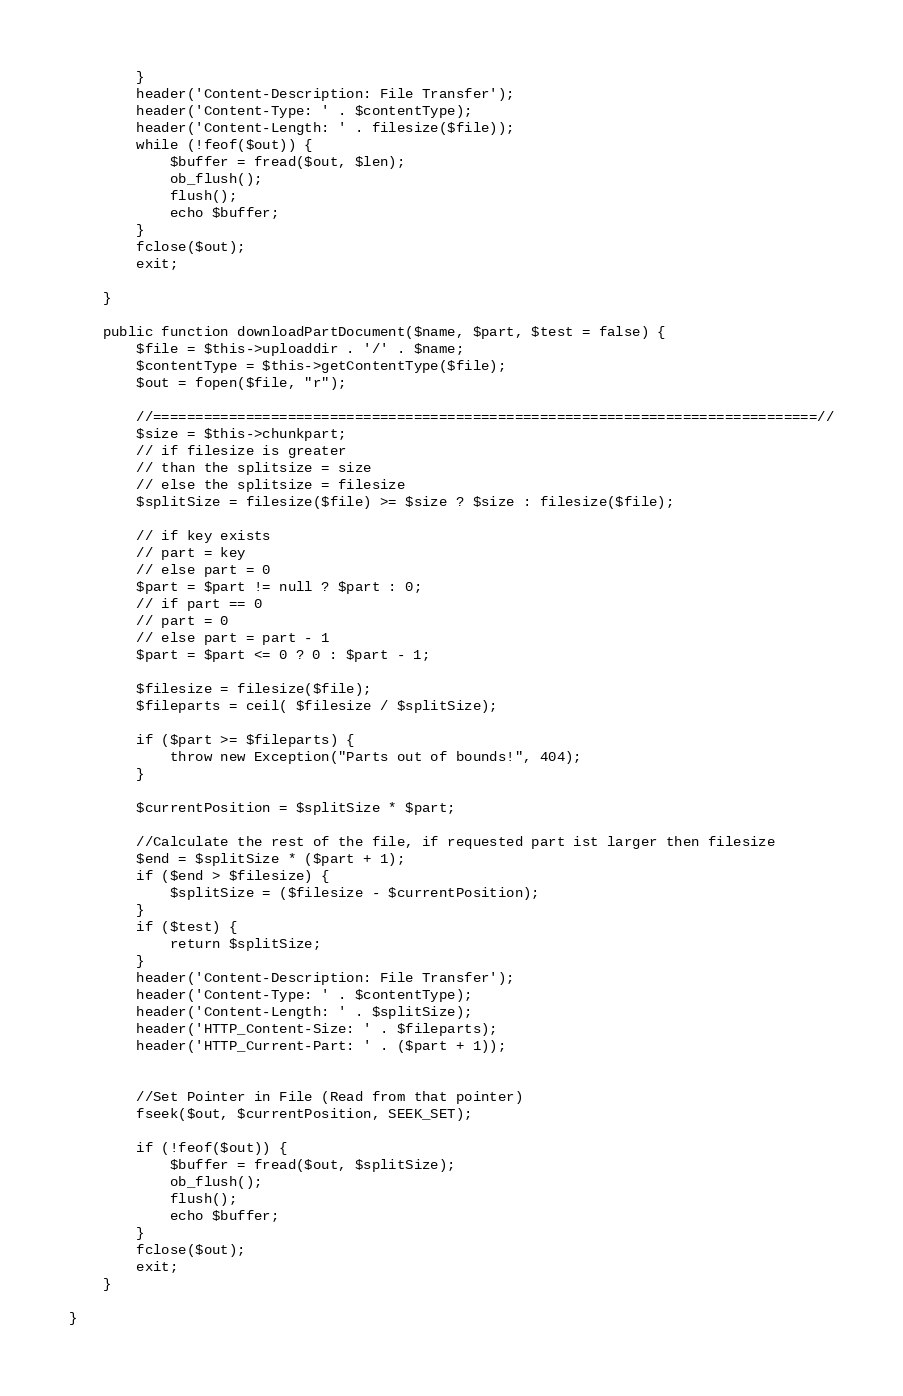Convert code to text. <code><loc_0><loc_0><loc_500><loc_500><_PHP_>        }
        header('Content-Description: File Transfer');
        header('Content-Type: ' . $contentType);
        header('Content-Length: ' . filesize($file));
        while (!feof($out)) {
            $buffer = fread($out, $len);
            ob_flush();
            flush();
            echo $buffer;
        }
        fclose($out);
        exit;

    }

    public function downloadPartDocument($name, $part, $test = false) {
        $file = $this->uploaddir . '/' . $name;
        $contentType = $this->getContentType($file);
        $out = fopen($file, "r");

        //===============================================================================//
        $size = $this->chunkpart;
        // if filesize is greater
        // than the splitsize = size
        // else the splitsize = filesize
        $splitSize = filesize($file) >= $size ? $size : filesize($file);

        // if key exists
        // part = key
        // else part = 0
        $part = $part != null ? $part : 0;
        // if part == 0
        // part = 0
        // else part = part - 1
        $part = $part <= 0 ? 0 : $part - 1;

        $filesize = filesize($file);
        $fileparts = ceil( $filesize / $splitSize);

        if ($part >= $fileparts) {
            throw new Exception("Parts out of bounds!", 404);
        }

        $currentPosition = $splitSize * $part;

        //Calculate the rest of the file, if requested part ist larger then filesize
        $end = $splitSize * ($part + 1);
        if ($end > $filesize) {
            $splitSize = ($filesize - $currentPosition);
        }
        if ($test) {
            return $splitSize;
        }
        header('Content-Description: File Transfer');
        header('Content-Type: ' . $contentType);
        header('Content-Length: ' . $splitSize);
        header('HTTP_Content-Size: ' . $fileparts);
        header('HTTP_Current-Part: ' . ($part + 1));


        //Set Pointer in File (Read from that pointer)
        fseek($out, $currentPosition, SEEK_SET);

        if (!feof($out)) {
            $buffer = fread($out, $splitSize);
            ob_flush();
            flush();
            echo $buffer;
        }
        fclose($out);
        exit;
    }

}</code> 